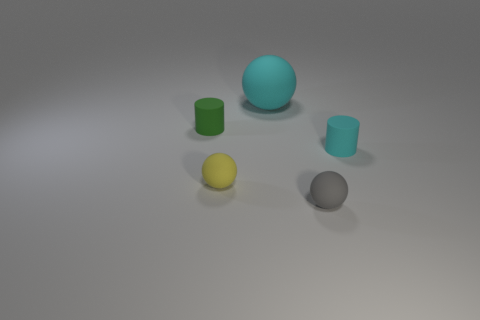There is a large cyan matte thing; does it have the same shape as the thing left of the yellow object?
Offer a very short reply. No. What is the color of the matte ball behind the cylinder that is in front of the small cylinder that is left of the small gray ball?
Make the answer very short. Cyan. There is a small matte thing that is right of the tiny gray object; is it the same shape as the tiny gray thing?
Provide a succinct answer. No. The big cyan rubber object to the left of the small matte cylinder that is right of the tiny matte ball on the left side of the tiny gray matte object is what shape?
Keep it short and to the point. Sphere. What number of other things are the same shape as the small cyan thing?
Your response must be concise. 1. There is a large matte object; does it have the same color as the small cylinder that is on the left side of the tiny cyan matte cylinder?
Provide a short and direct response. No. What number of small purple rubber spheres are there?
Ensure brevity in your answer.  0. How many things are green matte cylinders or small matte cylinders?
Keep it short and to the point. 2. What size is the rubber cylinder that is the same color as the large thing?
Offer a very short reply. Small. Are there any big cyan objects behind the big rubber sphere?
Make the answer very short. No. 